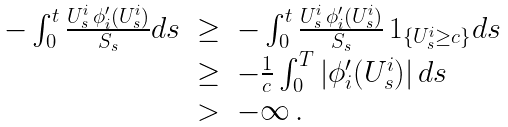Convert formula to latex. <formula><loc_0><loc_0><loc_500><loc_500>\begin{array} { l l l } - \int _ { 0 } ^ { t } \frac { U _ { s } ^ { i } \, \phi _ { i } ^ { \prime } ( U _ { s } ^ { i } ) } { S _ { s } } d s & \geq & - \int _ { 0 } ^ { t } \frac { U _ { s } ^ { i } \, \phi _ { i } ^ { \prime } ( U _ { s } ^ { i } ) } { S _ { s } } \, { 1 } _ { \{ U _ { s } ^ { i } \geq c \} } d s \\ & \geq & - \frac { 1 } { c } \int _ { 0 } ^ { T } | \phi _ { i } ^ { \prime } ( U _ { s } ^ { i } ) | \, d s \\ & > & - \infty \, . \end{array}</formula> 